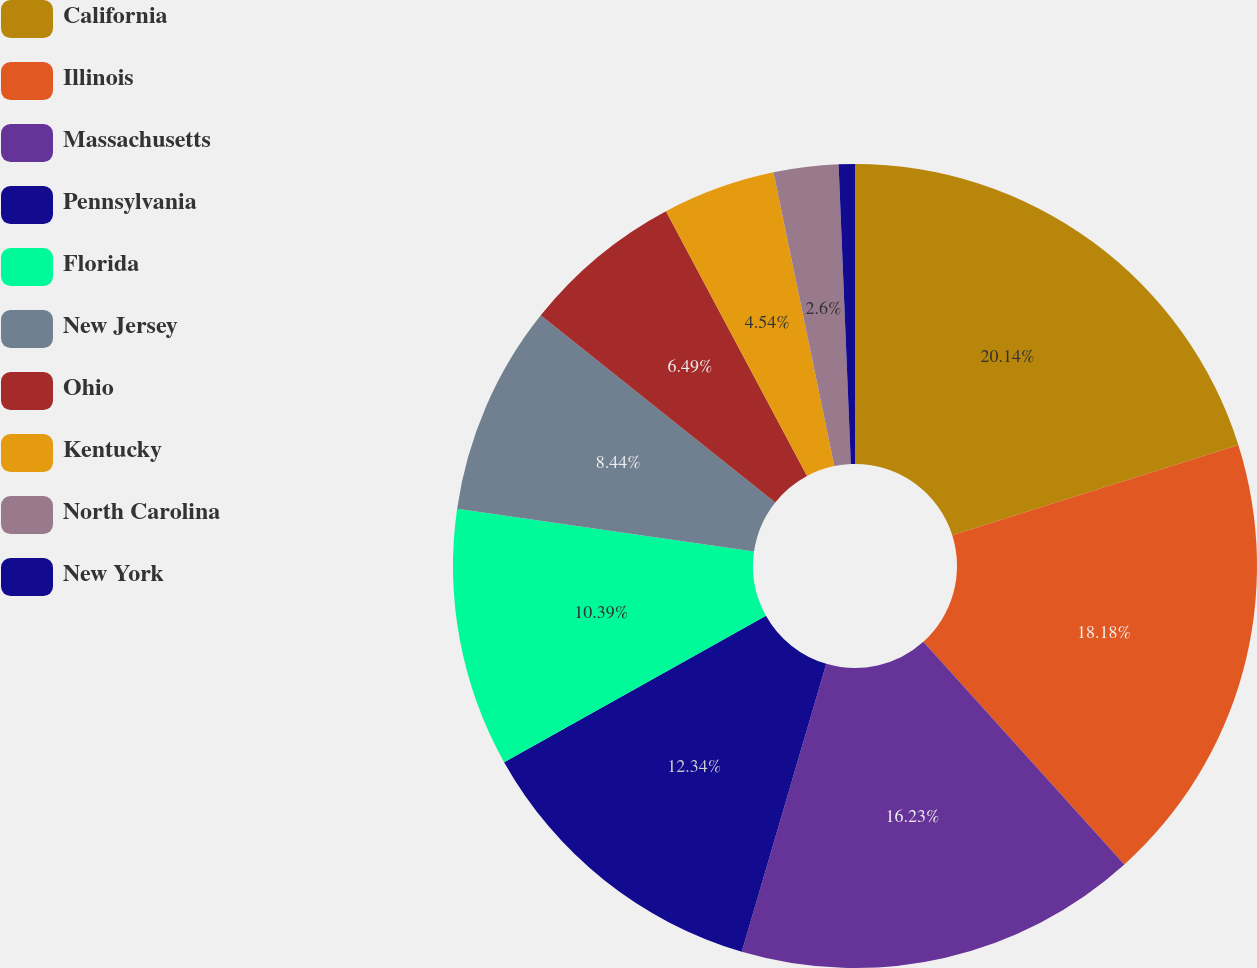Convert chart. <chart><loc_0><loc_0><loc_500><loc_500><pie_chart><fcel>California<fcel>Illinois<fcel>Massachusetts<fcel>Pennsylvania<fcel>Florida<fcel>New Jersey<fcel>Ohio<fcel>Kentucky<fcel>North Carolina<fcel>New York<nl><fcel>20.13%<fcel>18.18%<fcel>16.23%<fcel>12.34%<fcel>10.39%<fcel>8.44%<fcel>6.49%<fcel>4.54%<fcel>2.6%<fcel>0.65%<nl></chart> 